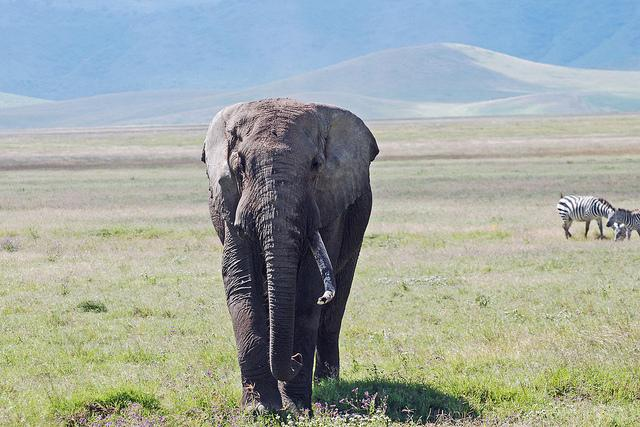What is the elephant missing on its right side? tusk 